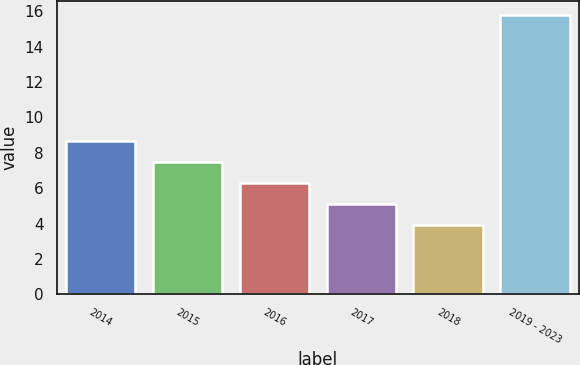Convert chart to OTSL. <chart><loc_0><loc_0><loc_500><loc_500><bar_chart><fcel>2014<fcel>2015<fcel>2016<fcel>2017<fcel>2018<fcel>2019 - 2023<nl><fcel>8.66<fcel>7.47<fcel>6.28<fcel>5.09<fcel>3.9<fcel>15.8<nl></chart> 